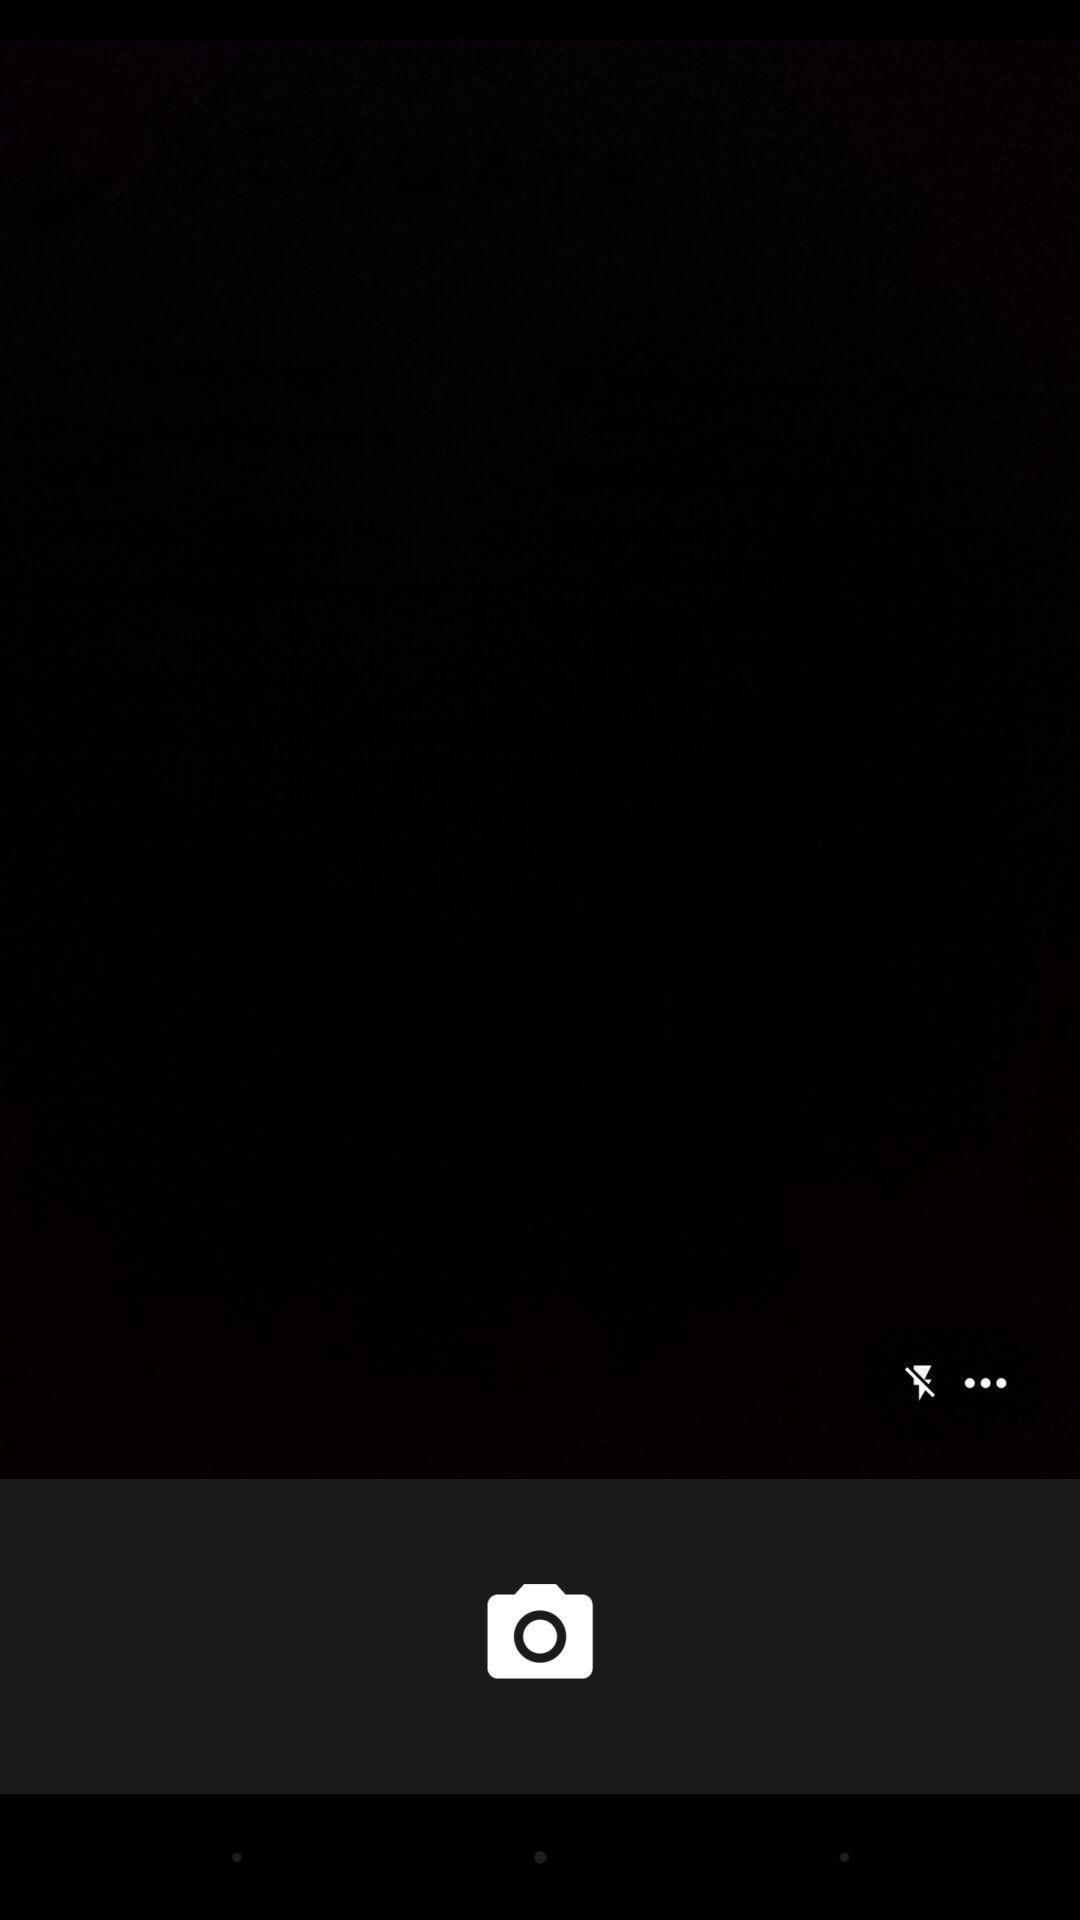Describe the key features of this screenshot. Screen shows a blank page of camera. 